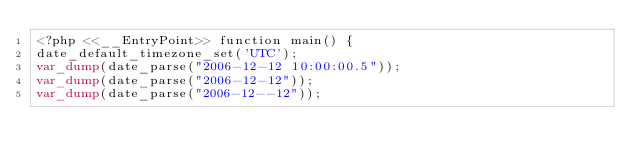Convert code to text. <code><loc_0><loc_0><loc_500><loc_500><_PHP_><?php <<__EntryPoint>> function main() {
date_default_timezone_set('UTC');
var_dump(date_parse("2006-12-12 10:00:00.5"));
var_dump(date_parse("2006-12-12"));
var_dump(date_parse("2006-12--12"));</code> 